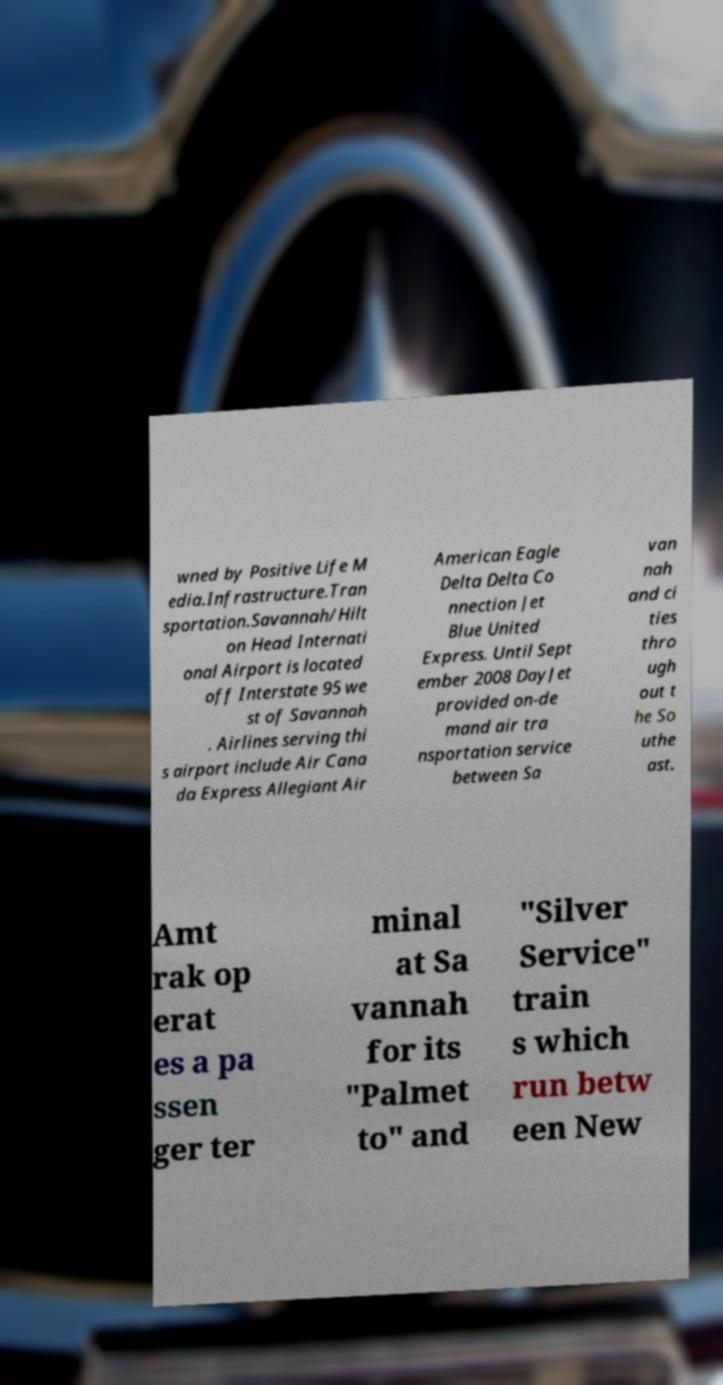For documentation purposes, I need the text within this image transcribed. Could you provide that? wned by Positive Life M edia.Infrastructure.Tran sportation.Savannah/Hilt on Head Internati onal Airport is located off Interstate 95 we st of Savannah . Airlines serving thi s airport include Air Cana da Express Allegiant Air American Eagle Delta Delta Co nnection Jet Blue United Express. Until Sept ember 2008 DayJet provided on-de mand air tra nsportation service between Sa van nah and ci ties thro ugh out t he So uthe ast. Amt rak op erat es a pa ssen ger ter minal at Sa vannah for its "Palmet to" and "Silver Service" train s which run betw een New 